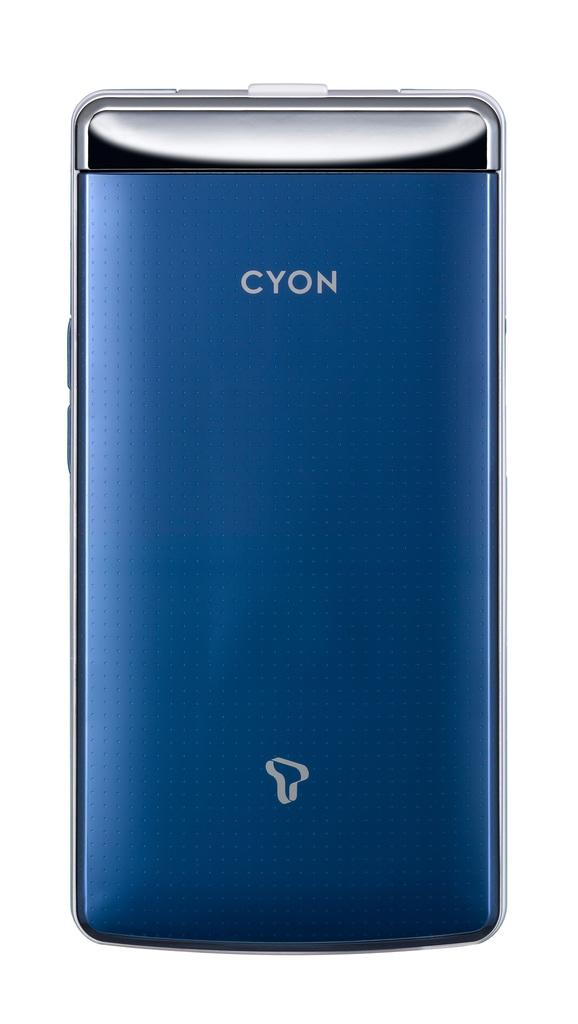Provide a one-sentence caption for the provided image. a blue smart phone brand cyon white screen on the back. 